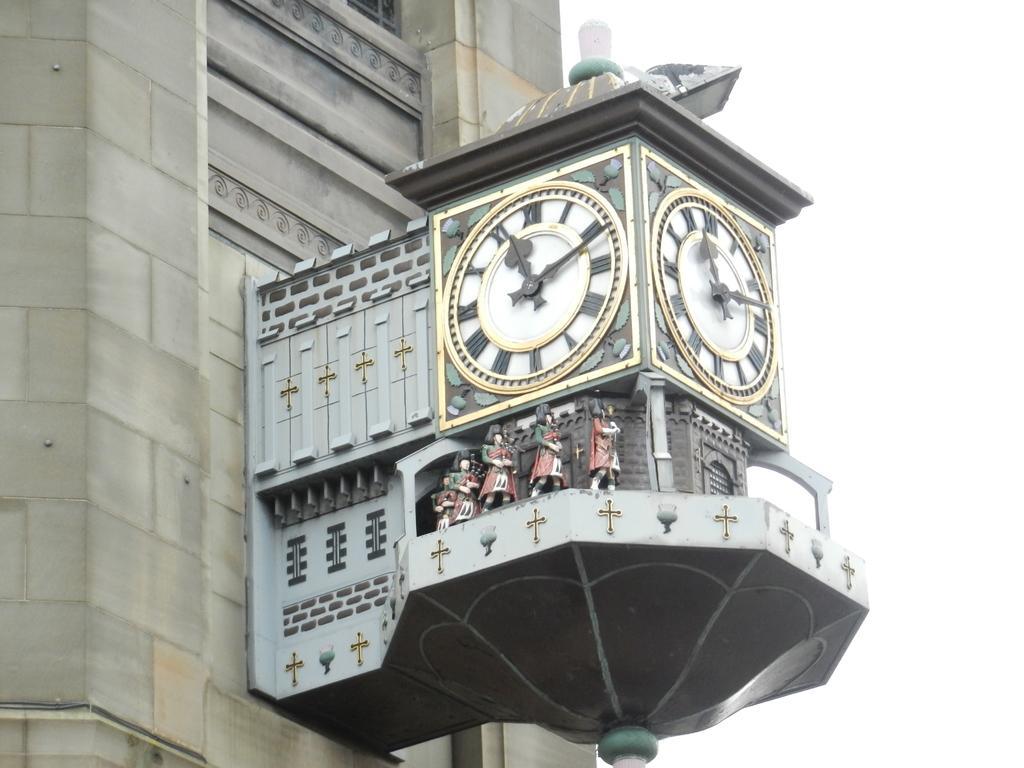Could you give a brief overview of what you see in this image? In this image I can see a building which is cream in color and to the building I can see a vintage clock which has four toys which are in the shape of person. In the background I can see the sky. 